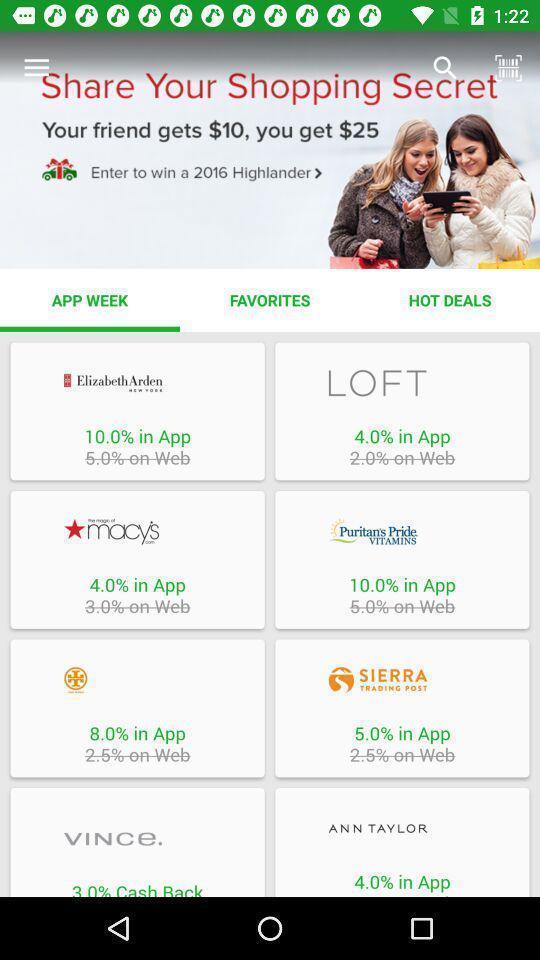Explain what's happening in this screen capture. Shopping page. 